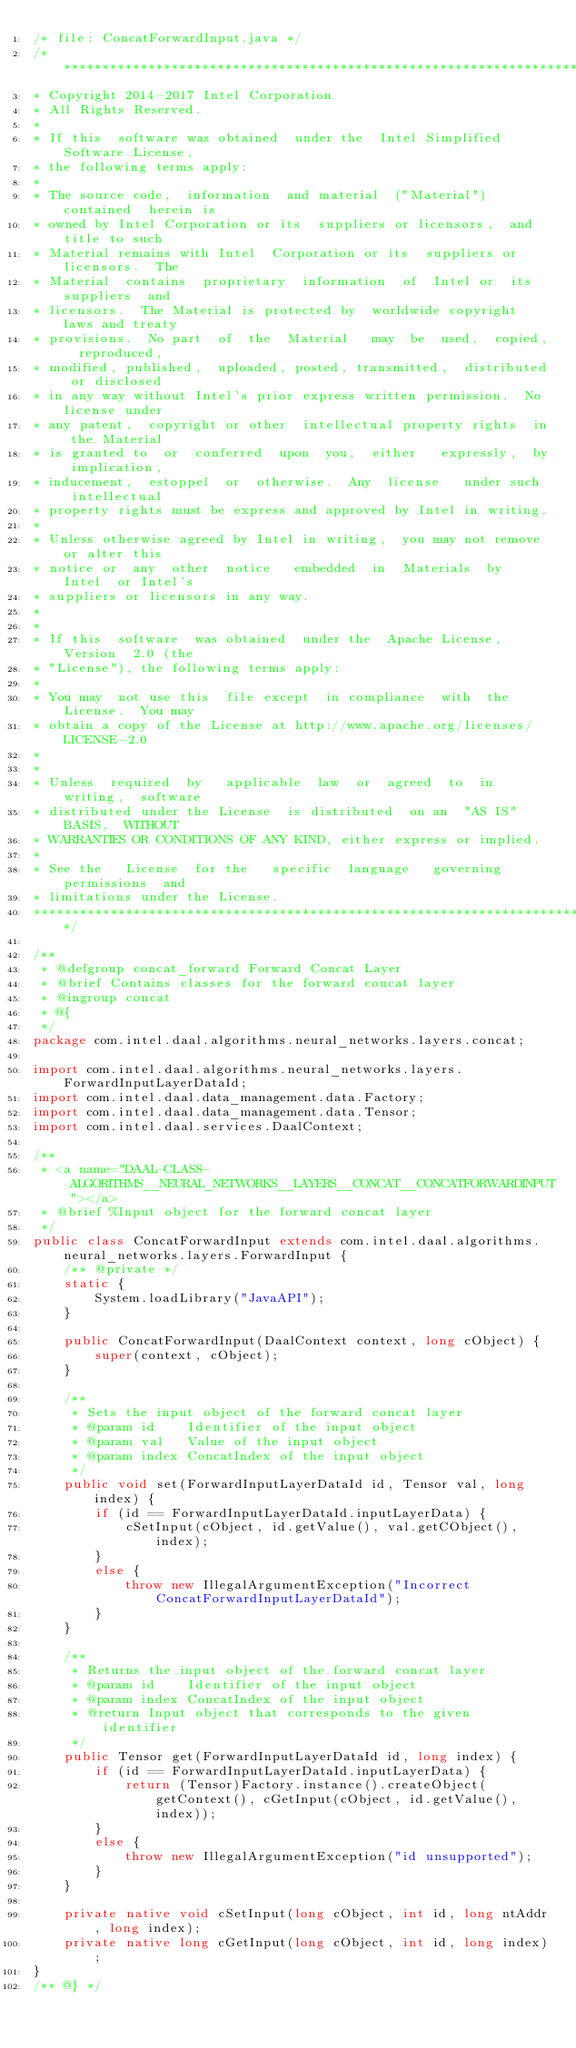<code> <loc_0><loc_0><loc_500><loc_500><_Java_>/* file: ConcatForwardInput.java */
/*******************************************************************************
* Copyright 2014-2017 Intel Corporation
* All Rights Reserved.
*
* If this  software was obtained  under the  Intel Simplified  Software License,
* the following terms apply:
*
* The source code,  information  and material  ("Material") contained  herein is
* owned by Intel Corporation or its  suppliers or licensors,  and  title to such
* Material remains with Intel  Corporation or its  suppliers or  licensors.  The
* Material  contains  proprietary  information  of  Intel or  its suppliers  and
* licensors.  The Material is protected by  worldwide copyright  laws and treaty
* provisions.  No part  of  the  Material   may  be  used,  copied,  reproduced,
* modified, published,  uploaded, posted, transmitted,  distributed or disclosed
* in any way without Intel's prior express written permission.  No license under
* any patent,  copyright or other  intellectual property rights  in the Material
* is granted to  or  conferred  upon  you,  either   expressly,  by implication,
* inducement,  estoppel  or  otherwise.  Any  license   under such  intellectual
* property rights must be express and approved by Intel in writing.
*
* Unless otherwise agreed by Intel in writing,  you may not remove or alter this
* notice or  any  other  notice   embedded  in  Materials  by  Intel  or Intel's
* suppliers or licensors in any way.
*
*
* If this  software  was obtained  under the  Apache License,  Version  2.0 (the
* "License"), the following terms apply:
*
* You may  not use this  file except  in compliance  with  the License.  You may
* obtain a copy of the License at http://www.apache.org/licenses/LICENSE-2.0
*
*
* Unless  required  by   applicable  law  or  agreed  to  in  writing,  software
* distributed under the License  is distributed  on an  "AS IS"  BASIS,  WITHOUT
* WARRANTIES OR CONDITIONS OF ANY KIND, either express or implied.
*
* See the   License  for the   specific  language   governing   permissions  and
* limitations under the License.
*******************************************************************************/

/**
 * @defgroup concat_forward Forward Concat Layer
 * @brief Contains classes for the forward concat layer
 * @ingroup concat
 * @{
 */
package com.intel.daal.algorithms.neural_networks.layers.concat;

import com.intel.daal.algorithms.neural_networks.layers.ForwardInputLayerDataId;
import com.intel.daal.data_management.data.Factory;
import com.intel.daal.data_management.data.Tensor;
import com.intel.daal.services.DaalContext;

/**
 * <a name="DAAL-CLASS-ALGORITHMS__NEURAL_NETWORKS__LAYERS__CONCAT__CONCATFORWARDINPUT"></a>
 * @brief %Input object for the forward concat layer
 */
public class ConcatForwardInput extends com.intel.daal.algorithms.neural_networks.layers.ForwardInput {
    /** @private */
    static {
        System.loadLibrary("JavaAPI");
    }

    public ConcatForwardInput(DaalContext context, long cObject) {
        super(context, cObject);
    }

    /**
     * Sets the input object of the forward concat layer
     * @param id    Identifier of the input object
     * @param val   Value of the input object
     * @param index ConcatIndex of the input object
     */
    public void set(ForwardInputLayerDataId id, Tensor val, long index) {
        if (id == ForwardInputLayerDataId.inputLayerData) {
            cSetInput(cObject, id.getValue(), val.getCObject(), index);
        }
        else {
            throw new IllegalArgumentException("Incorrect ConcatForwardInputLayerDataId");
        }
    }

    /**
     * Returns the input object of the forward concat layer
     * @param id    Identifier of the input object
     * @param index ConcatIndex of the input object
     * @return Input object that corresponds to the given identifier
     */
    public Tensor get(ForwardInputLayerDataId id, long index) {
        if (id == ForwardInputLayerDataId.inputLayerData) {
            return (Tensor)Factory.instance().createObject(getContext(), cGetInput(cObject, id.getValue(), index));
        }
        else {
            throw new IllegalArgumentException("id unsupported");
        }
    }

    private native void cSetInput(long cObject, int id, long ntAddr, long index);
    private native long cGetInput(long cObject, int id, long index);
}
/** @} */
</code> 